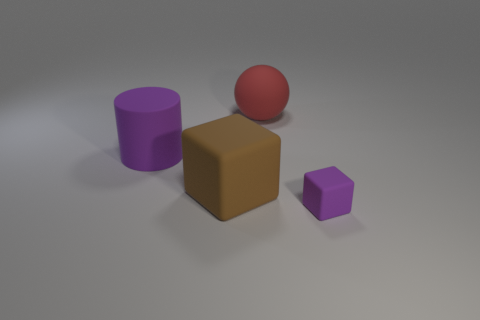Add 2 purple objects. How many objects exist? 6 Subtract all balls. How many objects are left? 3 Subtract 0 yellow spheres. How many objects are left? 4 Subtract all large purple cylinders. Subtract all small objects. How many objects are left? 2 Add 4 big brown objects. How many big brown objects are left? 5 Add 3 yellow shiny objects. How many yellow shiny objects exist? 3 